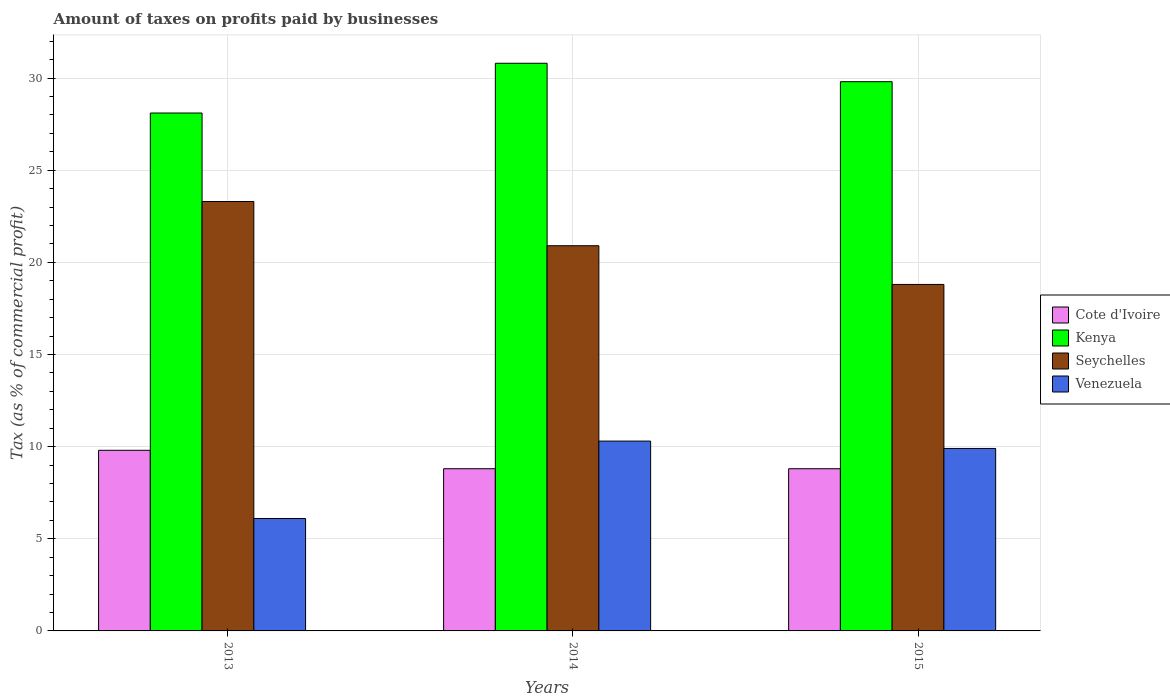Are the number of bars per tick equal to the number of legend labels?
Make the answer very short. Yes. What is the label of the 3rd group of bars from the left?
Offer a terse response. 2015. In how many cases, is the number of bars for a given year not equal to the number of legend labels?
Give a very brief answer. 0. What is the percentage of taxes paid by businesses in Venezuela in 2014?
Your answer should be very brief. 10.3. In which year was the percentage of taxes paid by businesses in Seychelles minimum?
Offer a terse response. 2015. What is the total percentage of taxes paid by businesses in Cote d'Ivoire in the graph?
Keep it short and to the point. 27.4. What is the difference between the percentage of taxes paid by businesses in Seychelles in 2015 and the percentage of taxes paid by businesses in Venezuela in 2013?
Your answer should be compact. 12.7. What is the average percentage of taxes paid by businesses in Venezuela per year?
Offer a very short reply. 8.77. In the year 2014, what is the difference between the percentage of taxes paid by businesses in Venezuela and percentage of taxes paid by businesses in Cote d'Ivoire?
Make the answer very short. 1.5. What is the ratio of the percentage of taxes paid by businesses in Seychelles in 2014 to that in 2015?
Offer a very short reply. 1.11. What is the difference between the highest and the second highest percentage of taxes paid by businesses in Kenya?
Your answer should be very brief. 1. What is the difference between the highest and the lowest percentage of taxes paid by businesses in Kenya?
Offer a very short reply. 2.7. Is the sum of the percentage of taxes paid by businesses in Seychelles in 2014 and 2015 greater than the maximum percentage of taxes paid by businesses in Venezuela across all years?
Keep it short and to the point. Yes. Is it the case that in every year, the sum of the percentage of taxes paid by businesses in Kenya and percentage of taxes paid by businesses in Seychelles is greater than the sum of percentage of taxes paid by businesses in Venezuela and percentage of taxes paid by businesses in Cote d'Ivoire?
Provide a succinct answer. Yes. What does the 2nd bar from the left in 2015 represents?
Your answer should be compact. Kenya. What does the 4th bar from the right in 2013 represents?
Offer a very short reply. Cote d'Ivoire. Is it the case that in every year, the sum of the percentage of taxes paid by businesses in Kenya and percentage of taxes paid by businesses in Seychelles is greater than the percentage of taxes paid by businesses in Cote d'Ivoire?
Offer a terse response. Yes. How many bars are there?
Provide a short and direct response. 12. How many years are there in the graph?
Your answer should be compact. 3. How many legend labels are there?
Ensure brevity in your answer.  4. How are the legend labels stacked?
Your response must be concise. Vertical. What is the title of the graph?
Offer a very short reply. Amount of taxes on profits paid by businesses. What is the label or title of the X-axis?
Your answer should be very brief. Years. What is the label or title of the Y-axis?
Offer a terse response. Tax (as % of commercial profit). What is the Tax (as % of commercial profit) of Kenya in 2013?
Make the answer very short. 28.1. What is the Tax (as % of commercial profit) in Seychelles in 2013?
Offer a terse response. 23.3. What is the Tax (as % of commercial profit) of Cote d'Ivoire in 2014?
Keep it short and to the point. 8.8. What is the Tax (as % of commercial profit) in Kenya in 2014?
Provide a short and direct response. 30.8. What is the Tax (as % of commercial profit) in Seychelles in 2014?
Provide a succinct answer. 20.9. What is the Tax (as % of commercial profit) in Venezuela in 2014?
Give a very brief answer. 10.3. What is the Tax (as % of commercial profit) in Kenya in 2015?
Keep it short and to the point. 29.8. Across all years, what is the maximum Tax (as % of commercial profit) in Cote d'Ivoire?
Your response must be concise. 9.8. Across all years, what is the maximum Tax (as % of commercial profit) of Kenya?
Give a very brief answer. 30.8. Across all years, what is the maximum Tax (as % of commercial profit) of Seychelles?
Offer a terse response. 23.3. Across all years, what is the minimum Tax (as % of commercial profit) of Kenya?
Offer a terse response. 28.1. What is the total Tax (as % of commercial profit) in Cote d'Ivoire in the graph?
Keep it short and to the point. 27.4. What is the total Tax (as % of commercial profit) in Kenya in the graph?
Offer a very short reply. 88.7. What is the total Tax (as % of commercial profit) of Seychelles in the graph?
Your answer should be very brief. 63. What is the total Tax (as % of commercial profit) of Venezuela in the graph?
Provide a short and direct response. 26.3. What is the difference between the Tax (as % of commercial profit) of Cote d'Ivoire in 2013 and that in 2014?
Your response must be concise. 1. What is the difference between the Tax (as % of commercial profit) of Kenya in 2013 and that in 2014?
Make the answer very short. -2.7. What is the difference between the Tax (as % of commercial profit) in Seychelles in 2013 and that in 2015?
Offer a very short reply. 4.5. What is the difference between the Tax (as % of commercial profit) in Seychelles in 2014 and that in 2015?
Your answer should be compact. 2.1. What is the difference between the Tax (as % of commercial profit) of Venezuela in 2014 and that in 2015?
Make the answer very short. 0.4. What is the difference between the Tax (as % of commercial profit) in Cote d'Ivoire in 2013 and the Tax (as % of commercial profit) in Venezuela in 2014?
Offer a terse response. -0.5. What is the difference between the Tax (as % of commercial profit) in Kenya in 2013 and the Tax (as % of commercial profit) in Seychelles in 2014?
Make the answer very short. 7.2. What is the difference between the Tax (as % of commercial profit) of Seychelles in 2013 and the Tax (as % of commercial profit) of Venezuela in 2014?
Ensure brevity in your answer.  13. What is the difference between the Tax (as % of commercial profit) in Cote d'Ivoire in 2013 and the Tax (as % of commercial profit) in Kenya in 2015?
Your answer should be compact. -20. What is the difference between the Tax (as % of commercial profit) of Cote d'Ivoire in 2013 and the Tax (as % of commercial profit) of Venezuela in 2015?
Your answer should be very brief. -0.1. What is the difference between the Tax (as % of commercial profit) of Kenya in 2013 and the Tax (as % of commercial profit) of Seychelles in 2015?
Ensure brevity in your answer.  9.3. What is the difference between the Tax (as % of commercial profit) of Seychelles in 2013 and the Tax (as % of commercial profit) of Venezuela in 2015?
Keep it short and to the point. 13.4. What is the difference between the Tax (as % of commercial profit) in Kenya in 2014 and the Tax (as % of commercial profit) in Venezuela in 2015?
Make the answer very short. 20.9. What is the difference between the Tax (as % of commercial profit) of Seychelles in 2014 and the Tax (as % of commercial profit) of Venezuela in 2015?
Make the answer very short. 11. What is the average Tax (as % of commercial profit) in Cote d'Ivoire per year?
Your answer should be very brief. 9.13. What is the average Tax (as % of commercial profit) in Kenya per year?
Offer a terse response. 29.57. What is the average Tax (as % of commercial profit) of Venezuela per year?
Offer a very short reply. 8.77. In the year 2013, what is the difference between the Tax (as % of commercial profit) in Cote d'Ivoire and Tax (as % of commercial profit) in Kenya?
Make the answer very short. -18.3. In the year 2013, what is the difference between the Tax (as % of commercial profit) in Cote d'Ivoire and Tax (as % of commercial profit) in Venezuela?
Your response must be concise. 3.7. In the year 2013, what is the difference between the Tax (as % of commercial profit) in Kenya and Tax (as % of commercial profit) in Seychelles?
Offer a very short reply. 4.8. In the year 2013, what is the difference between the Tax (as % of commercial profit) in Kenya and Tax (as % of commercial profit) in Venezuela?
Your answer should be compact. 22. In the year 2013, what is the difference between the Tax (as % of commercial profit) in Seychelles and Tax (as % of commercial profit) in Venezuela?
Provide a succinct answer. 17.2. In the year 2014, what is the difference between the Tax (as % of commercial profit) of Cote d'Ivoire and Tax (as % of commercial profit) of Kenya?
Provide a succinct answer. -22. In the year 2014, what is the difference between the Tax (as % of commercial profit) of Cote d'Ivoire and Tax (as % of commercial profit) of Seychelles?
Give a very brief answer. -12.1. In the year 2014, what is the difference between the Tax (as % of commercial profit) of Seychelles and Tax (as % of commercial profit) of Venezuela?
Ensure brevity in your answer.  10.6. In the year 2015, what is the difference between the Tax (as % of commercial profit) in Cote d'Ivoire and Tax (as % of commercial profit) in Kenya?
Provide a succinct answer. -21. In the year 2015, what is the difference between the Tax (as % of commercial profit) of Cote d'Ivoire and Tax (as % of commercial profit) of Seychelles?
Your answer should be very brief. -10. In the year 2015, what is the difference between the Tax (as % of commercial profit) in Kenya and Tax (as % of commercial profit) in Seychelles?
Offer a terse response. 11. What is the ratio of the Tax (as % of commercial profit) in Cote d'Ivoire in 2013 to that in 2014?
Make the answer very short. 1.11. What is the ratio of the Tax (as % of commercial profit) of Kenya in 2013 to that in 2014?
Your answer should be compact. 0.91. What is the ratio of the Tax (as % of commercial profit) of Seychelles in 2013 to that in 2014?
Make the answer very short. 1.11. What is the ratio of the Tax (as % of commercial profit) in Venezuela in 2013 to that in 2014?
Ensure brevity in your answer.  0.59. What is the ratio of the Tax (as % of commercial profit) of Cote d'Ivoire in 2013 to that in 2015?
Your response must be concise. 1.11. What is the ratio of the Tax (as % of commercial profit) in Kenya in 2013 to that in 2015?
Ensure brevity in your answer.  0.94. What is the ratio of the Tax (as % of commercial profit) of Seychelles in 2013 to that in 2015?
Your answer should be compact. 1.24. What is the ratio of the Tax (as % of commercial profit) in Venezuela in 2013 to that in 2015?
Your answer should be compact. 0.62. What is the ratio of the Tax (as % of commercial profit) in Cote d'Ivoire in 2014 to that in 2015?
Ensure brevity in your answer.  1. What is the ratio of the Tax (as % of commercial profit) in Kenya in 2014 to that in 2015?
Your answer should be compact. 1.03. What is the ratio of the Tax (as % of commercial profit) of Seychelles in 2014 to that in 2015?
Make the answer very short. 1.11. What is the ratio of the Tax (as % of commercial profit) in Venezuela in 2014 to that in 2015?
Offer a terse response. 1.04. What is the difference between the highest and the second highest Tax (as % of commercial profit) of Cote d'Ivoire?
Your response must be concise. 1. What is the difference between the highest and the second highest Tax (as % of commercial profit) in Venezuela?
Your answer should be compact. 0.4. What is the difference between the highest and the lowest Tax (as % of commercial profit) of Cote d'Ivoire?
Give a very brief answer. 1. What is the difference between the highest and the lowest Tax (as % of commercial profit) of Venezuela?
Provide a succinct answer. 4.2. 